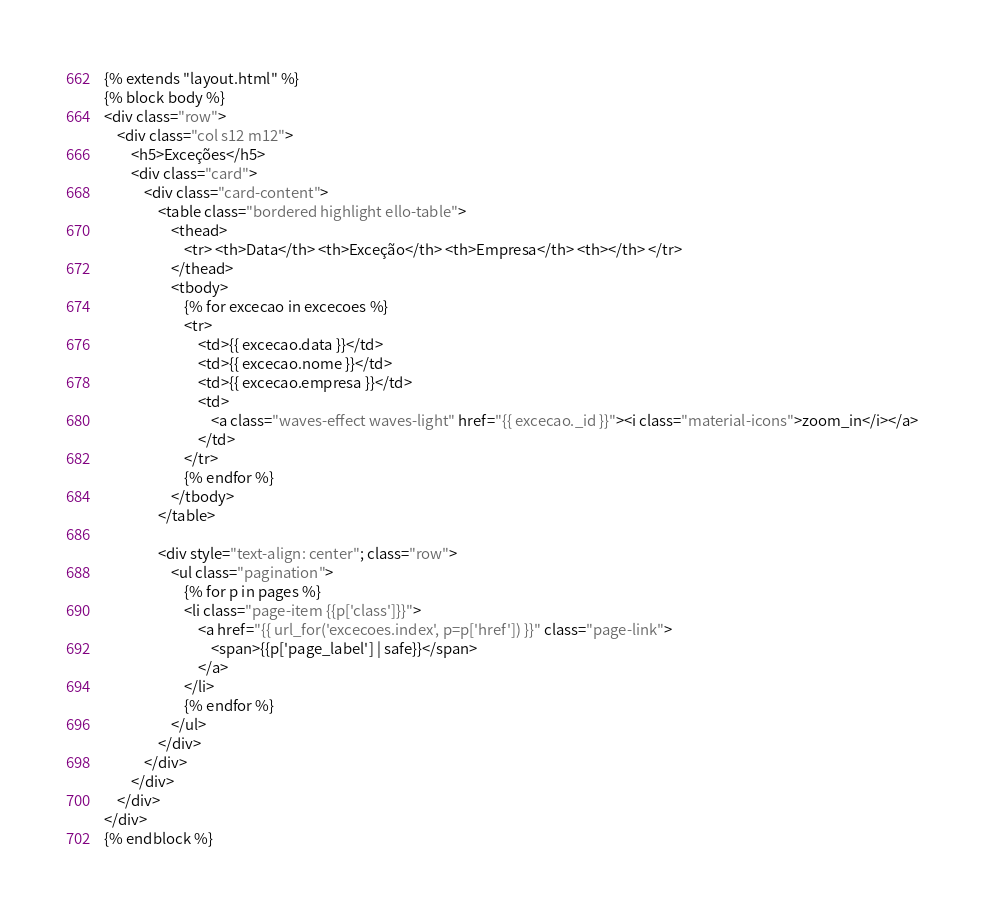<code> <loc_0><loc_0><loc_500><loc_500><_HTML_>{% extends "layout.html" %}
{% block body %}
<div class="row">
    <div class="col s12 m12">
        <h5>Exceções</h5>
        <div class="card">
            <div class="card-content">
                <table class="bordered highlight ello-table">
                    <thead>
                        <tr> <th>Data</th> <th>Exceção</th> <th>Empresa</th> <th></th> </tr>
                    </thead>
                    <tbody>
                        {% for excecao in excecoes %}
                        <tr>
                            <td>{{ excecao.data }}</td>
                            <td>{{ excecao.nome }}</td>
                            <td>{{ excecao.empresa }}</td>
                            <td>
                                <a class="waves-effect waves-light" href="{{ excecao._id }}"><i class="material-icons">zoom_in</i></a>
                            </td>
                        </tr>
                        {% endfor %}
                    </tbody>
                </table>

                <div style="text-align: center"; class="row">
                    <ul class="pagination">
                        {% for p in pages %}
                        <li class="page-item {{p['class']}}">
                            <a href="{{ url_for('excecoes.index', p=p['href']) }}" class="page-link">
                                <span>{{p['page_label'] | safe}}</span>
                            </a>
                        </li>
                        {% endfor %}
                    </ul>
                </div>    
            </div>
        </div>
    </div>
</div>
{% endblock %}
</code> 